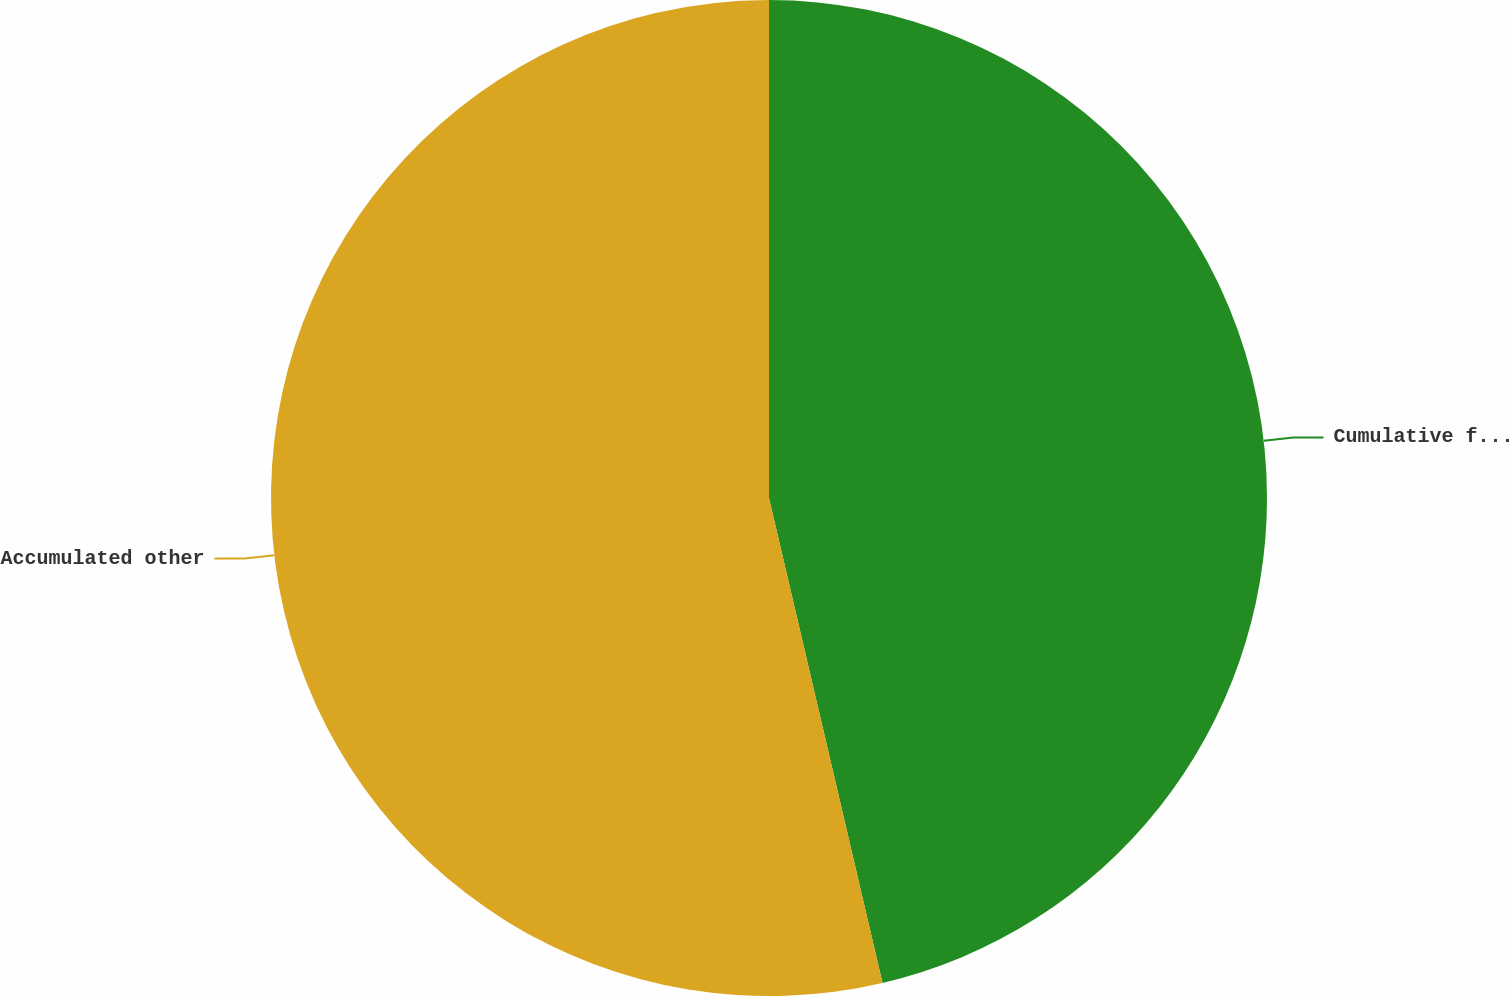Convert chart. <chart><loc_0><loc_0><loc_500><loc_500><pie_chart><fcel>Cumulative foreign currency<fcel>Accumulated other<nl><fcel>46.34%<fcel>53.66%<nl></chart> 